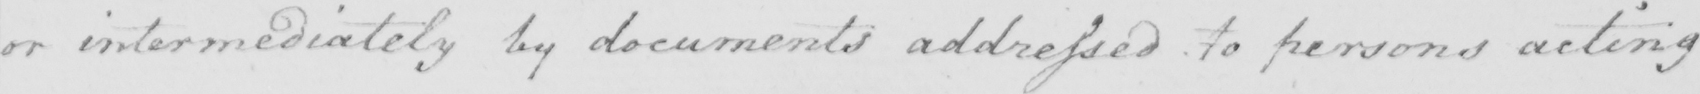What does this handwritten line say? or intermediately by documents addressed to persons acting 